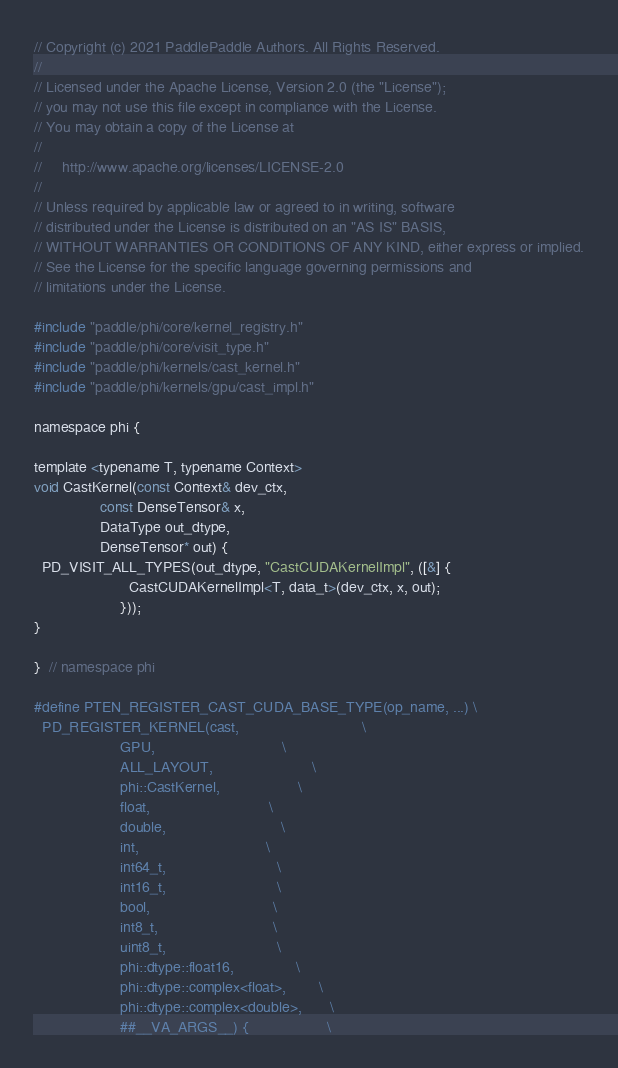<code> <loc_0><loc_0><loc_500><loc_500><_Cuda_>// Copyright (c) 2021 PaddlePaddle Authors. All Rights Reserved.
//
// Licensed under the Apache License, Version 2.0 (the "License");
// you may not use this file except in compliance with the License.
// You may obtain a copy of the License at
//
//     http://www.apache.org/licenses/LICENSE-2.0
//
// Unless required by applicable law or agreed to in writing, software
// distributed under the License is distributed on an "AS IS" BASIS,
// WITHOUT WARRANTIES OR CONDITIONS OF ANY KIND, either express or implied.
// See the License for the specific language governing permissions and
// limitations under the License.

#include "paddle/phi/core/kernel_registry.h"
#include "paddle/phi/core/visit_type.h"
#include "paddle/phi/kernels/cast_kernel.h"
#include "paddle/phi/kernels/gpu/cast_impl.h"

namespace phi {

template <typename T, typename Context>
void CastKernel(const Context& dev_ctx,
                const DenseTensor& x,
                DataType out_dtype,
                DenseTensor* out) {
  PD_VISIT_ALL_TYPES(out_dtype, "CastCUDAKernelImpl", ([&] {
                       CastCUDAKernelImpl<T, data_t>(dev_ctx, x, out);
                     }));
}

}  // namespace phi

#define PTEN_REGISTER_CAST_CUDA_BASE_TYPE(op_name, ...) \
  PD_REGISTER_KERNEL(cast,                              \
                     GPU,                               \
                     ALL_LAYOUT,                        \
                     phi::CastKernel,                   \
                     float,                             \
                     double,                            \
                     int,                               \
                     int64_t,                           \
                     int16_t,                           \
                     bool,                              \
                     int8_t,                            \
                     uint8_t,                           \
                     phi::dtype::float16,               \
                     phi::dtype::complex<float>,        \
                     phi::dtype::complex<double>,       \
                     ##__VA_ARGS__) {                   \</code> 